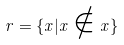Convert formula to latex. <formula><loc_0><loc_0><loc_500><loc_500>r = \{ x | x \notin x \}</formula> 